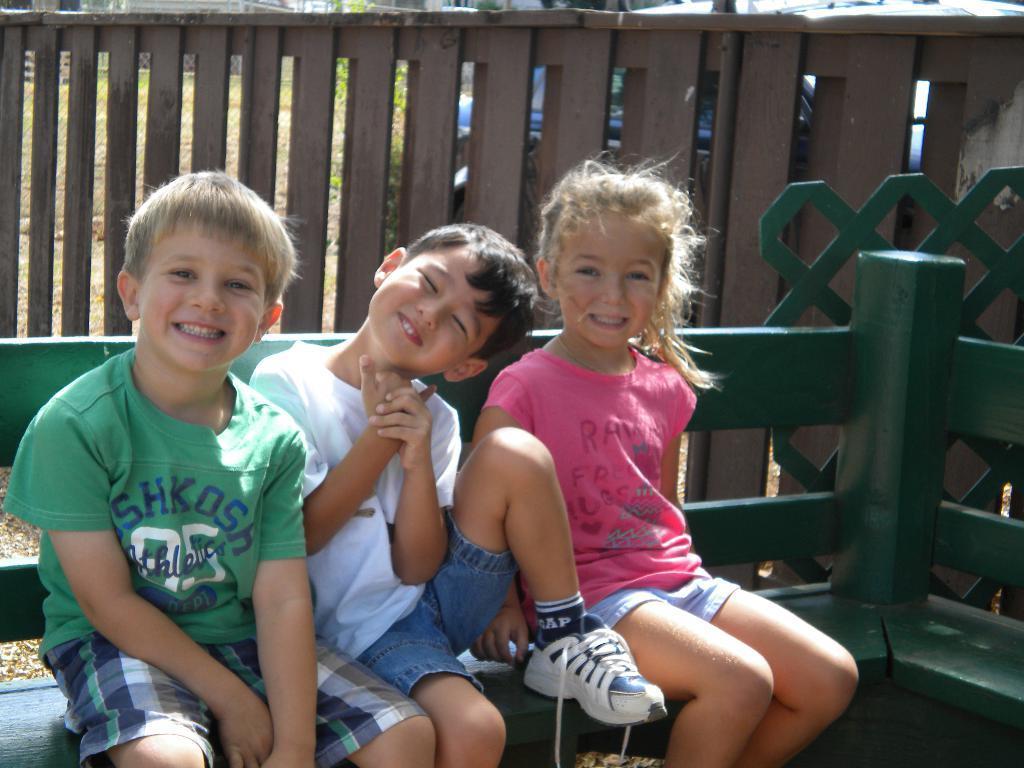In one or two sentences, can you explain what this image depicts? In this image I can see three children are sitting on the bench, they wore t-shirt, short and they are smiling. Behind them there is the wooden fence. 